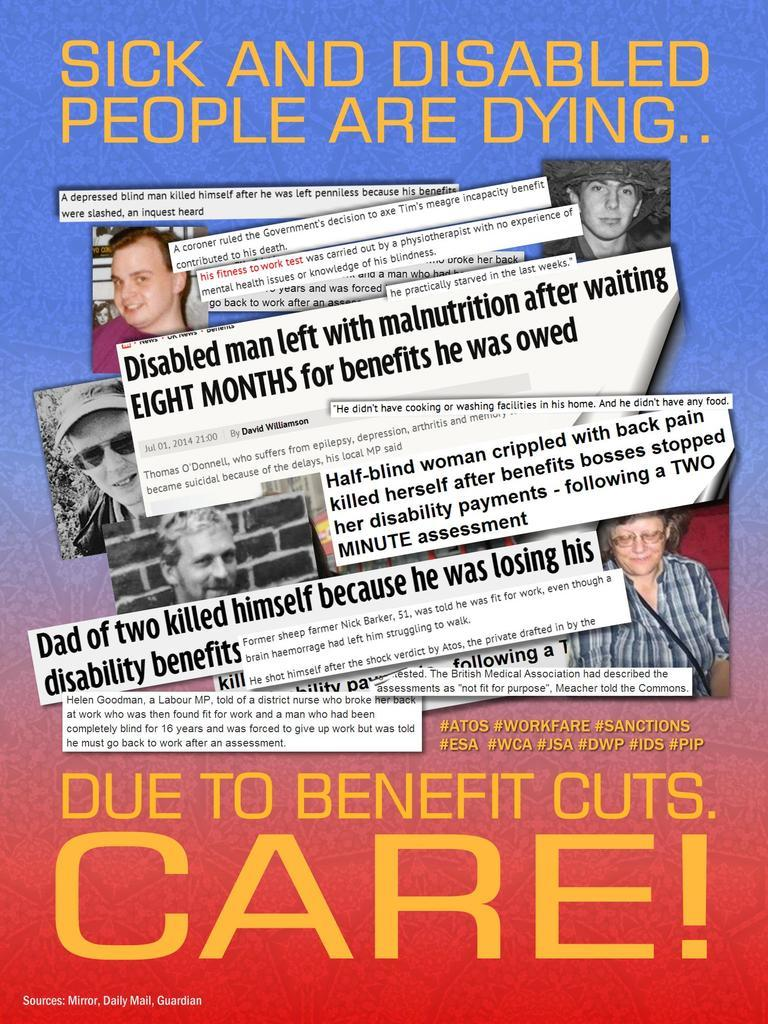Provide a one-sentence caption for the provided image. A political poster which claims that sick and disabled people are dying. 